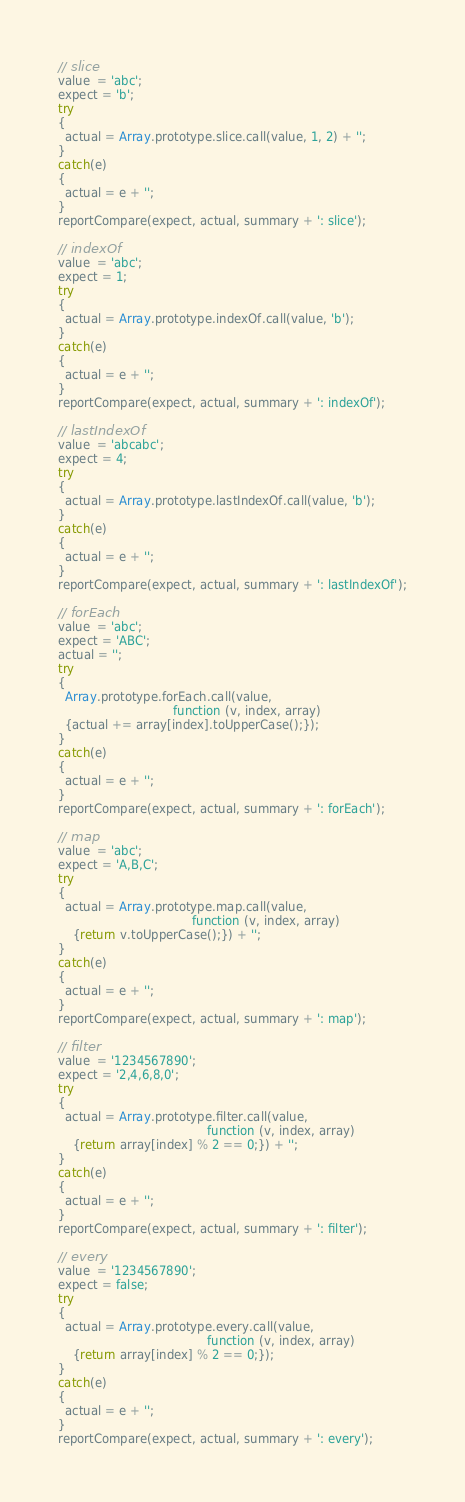<code> <loc_0><loc_0><loc_500><loc_500><_JavaScript_>// slice
value  = 'abc';
expect = 'b';
try
{
  actual = Array.prototype.slice.call(value, 1, 2) + '';
}
catch(e)
{
  actual = e + '';
}
reportCompare(expect, actual, summary + ': slice');

// indexOf
value  = 'abc';
expect = 1;
try
{
  actual = Array.prototype.indexOf.call(value, 'b');
}
catch(e)
{
  actual = e + '';
}
reportCompare(expect, actual, summary + ': indexOf');

// lastIndexOf
value  = 'abcabc';
expect = 4;
try
{
  actual = Array.prototype.lastIndexOf.call(value, 'b');
}
catch(e)
{
  actual = e + '';
}
reportCompare(expect, actual, summary + ': lastIndexOf');

// forEach
value  = 'abc';
expect = 'ABC';
actual = '';
try
{
  Array.prototype.forEach.call(value, 
                               function (v, index, array) 
  {actual += array[index].toUpperCase();});
}
catch(e)
{
  actual = e + '';
}
reportCompare(expect, actual, summary + ': forEach');

// map
value  = 'abc';
expect = 'A,B,C';
try
{
  actual = Array.prototype.map.call(value, 
                                    function (v, index, array) 
    {return v.toUpperCase();}) + '';
}
catch(e)
{
  actual = e + '';
}
reportCompare(expect, actual, summary + ': map');

// filter
value  = '1234567890';
expect = '2,4,6,8,0';
try
{
  actual = Array.prototype.filter.call(value, 
                                        function (v, index, array) 
    {return array[index] % 2 == 0;}) + '';
}
catch(e)
{
  actual = e + '';
}
reportCompare(expect, actual, summary + ': filter');

// every
value  = '1234567890';
expect = false;
try
{
  actual = Array.prototype.every.call(value, 
                                        function (v, index, array) 
    {return array[index] % 2 == 0;});
}
catch(e)
{
  actual = e + '';
}
reportCompare(expect, actual, summary + ': every');



</code> 